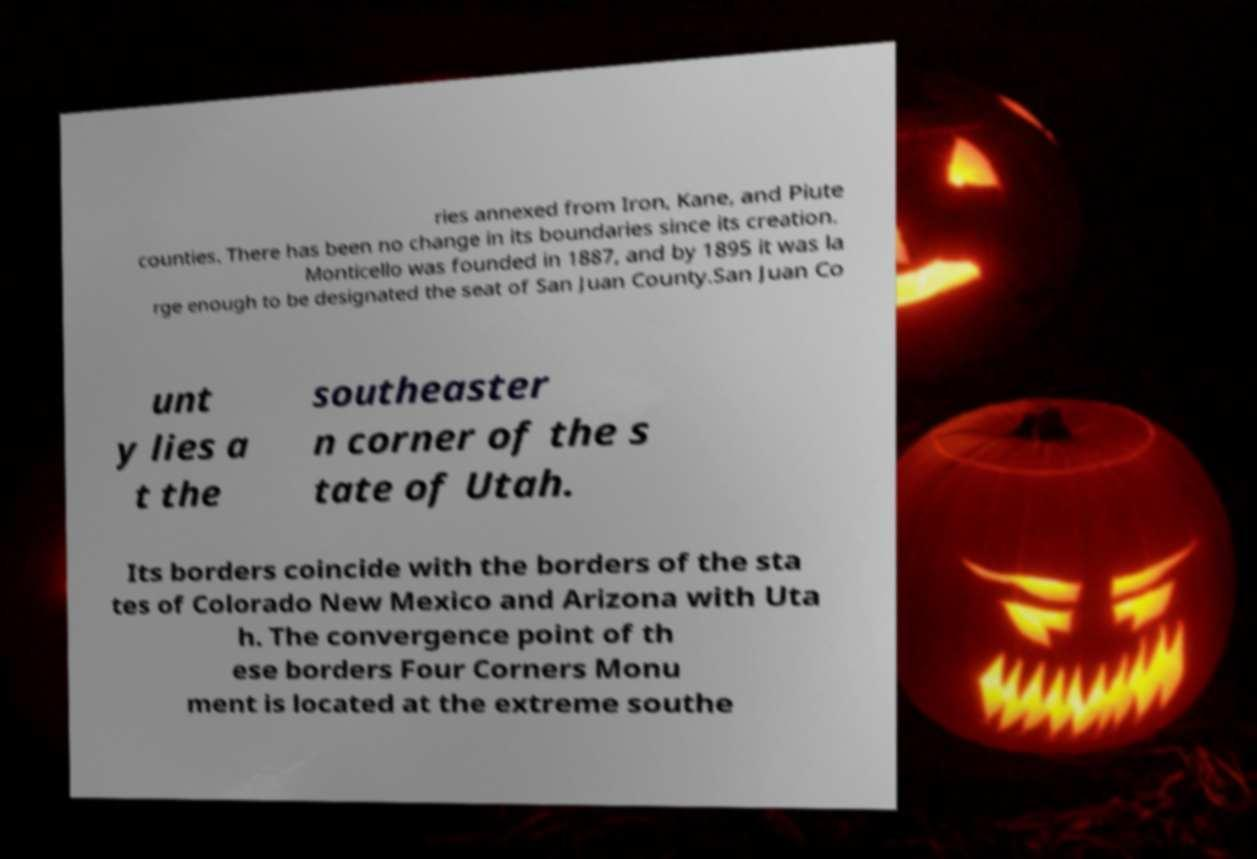Can you accurately transcribe the text from the provided image for me? ries annexed from Iron, Kane, and Piute counties. There has been no change in its boundaries since its creation. Monticello was founded in 1887, and by 1895 it was la rge enough to be designated the seat of San Juan County.San Juan Co unt y lies a t the southeaster n corner of the s tate of Utah. Its borders coincide with the borders of the sta tes of Colorado New Mexico and Arizona with Uta h. The convergence point of th ese borders Four Corners Monu ment is located at the extreme southe 